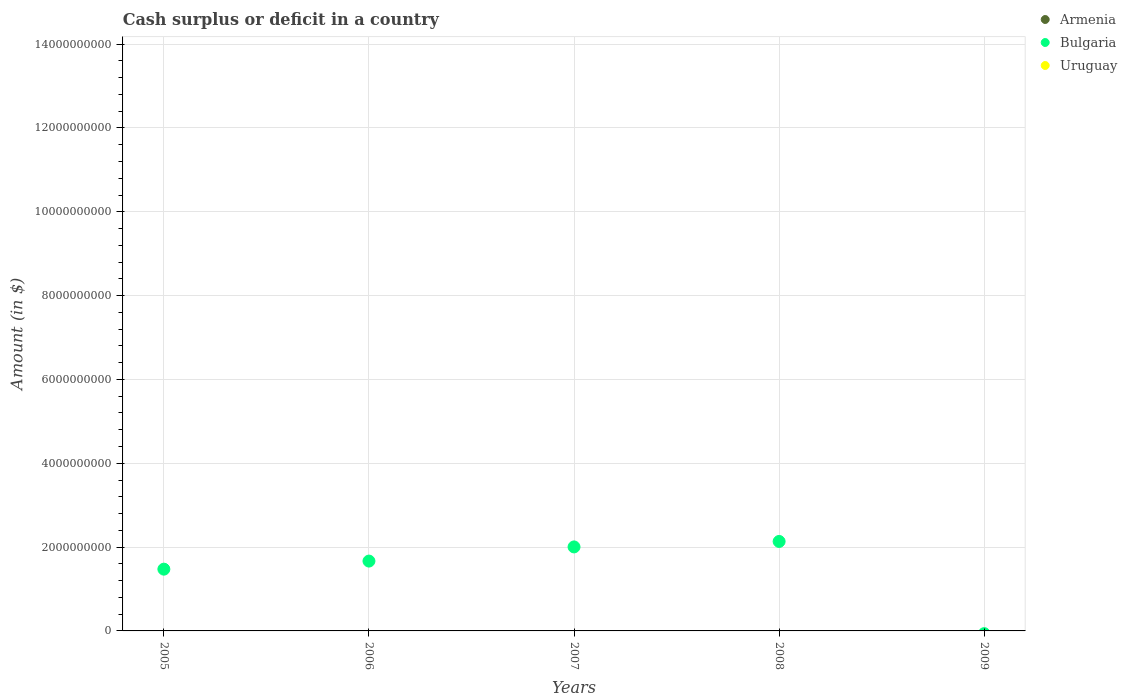How many different coloured dotlines are there?
Offer a very short reply. 1. What is the amount of cash surplus or deficit in Armenia in 2008?
Ensure brevity in your answer.  0. In which year was the amount of cash surplus or deficit in Bulgaria maximum?
Give a very brief answer. 2008. What is the total amount of cash surplus or deficit in Uruguay in the graph?
Your answer should be very brief. 0. What is the difference between the amount of cash surplus or deficit in Bulgaria in 2005 and that in 2006?
Your answer should be compact. -1.93e+08. What is the difference between the amount of cash surplus or deficit in Bulgaria in 2007 and the amount of cash surplus or deficit in Armenia in 2009?
Your response must be concise. 2.00e+09. What is the average amount of cash surplus or deficit in Bulgaria per year?
Make the answer very short. 1.46e+09. In how many years, is the amount of cash surplus or deficit in Uruguay greater than 13200000000 $?
Ensure brevity in your answer.  0. What is the ratio of the amount of cash surplus or deficit in Bulgaria in 2005 to that in 2008?
Your answer should be very brief. 0.69. What is the difference between the highest and the lowest amount of cash surplus or deficit in Bulgaria?
Your answer should be very brief. 2.13e+09. Is the sum of the amount of cash surplus or deficit in Bulgaria in 2005 and 2007 greater than the maximum amount of cash surplus or deficit in Armenia across all years?
Keep it short and to the point. Yes. How many years are there in the graph?
Keep it short and to the point. 5. What is the difference between two consecutive major ticks on the Y-axis?
Your answer should be compact. 2.00e+09. Are the values on the major ticks of Y-axis written in scientific E-notation?
Make the answer very short. No. Where does the legend appear in the graph?
Your answer should be very brief. Top right. How many legend labels are there?
Your answer should be compact. 3. How are the legend labels stacked?
Ensure brevity in your answer.  Vertical. What is the title of the graph?
Your answer should be very brief. Cash surplus or deficit in a country. What is the label or title of the Y-axis?
Make the answer very short. Amount (in $). What is the Amount (in $) of Bulgaria in 2005?
Make the answer very short. 1.47e+09. What is the Amount (in $) in Uruguay in 2005?
Ensure brevity in your answer.  0. What is the Amount (in $) in Bulgaria in 2006?
Ensure brevity in your answer.  1.67e+09. What is the Amount (in $) of Uruguay in 2006?
Your answer should be very brief. 0. What is the Amount (in $) in Bulgaria in 2007?
Offer a very short reply. 2.00e+09. What is the Amount (in $) in Bulgaria in 2008?
Give a very brief answer. 2.13e+09. What is the Amount (in $) of Uruguay in 2008?
Ensure brevity in your answer.  0. What is the Amount (in $) of Uruguay in 2009?
Provide a short and direct response. 0. Across all years, what is the maximum Amount (in $) in Bulgaria?
Offer a very short reply. 2.13e+09. What is the total Amount (in $) of Armenia in the graph?
Your response must be concise. 0. What is the total Amount (in $) in Bulgaria in the graph?
Make the answer very short. 7.28e+09. What is the total Amount (in $) of Uruguay in the graph?
Offer a very short reply. 0. What is the difference between the Amount (in $) of Bulgaria in 2005 and that in 2006?
Give a very brief answer. -1.93e+08. What is the difference between the Amount (in $) of Bulgaria in 2005 and that in 2007?
Offer a terse response. -5.31e+08. What is the difference between the Amount (in $) in Bulgaria in 2005 and that in 2008?
Your answer should be compact. -6.61e+08. What is the difference between the Amount (in $) of Bulgaria in 2006 and that in 2007?
Your answer should be compact. -3.38e+08. What is the difference between the Amount (in $) in Bulgaria in 2006 and that in 2008?
Give a very brief answer. -4.68e+08. What is the difference between the Amount (in $) in Bulgaria in 2007 and that in 2008?
Offer a very short reply. -1.30e+08. What is the average Amount (in $) of Bulgaria per year?
Your answer should be very brief. 1.46e+09. What is the ratio of the Amount (in $) of Bulgaria in 2005 to that in 2006?
Offer a terse response. 0.88. What is the ratio of the Amount (in $) in Bulgaria in 2005 to that in 2007?
Provide a succinct answer. 0.74. What is the ratio of the Amount (in $) in Bulgaria in 2005 to that in 2008?
Your answer should be compact. 0.69. What is the ratio of the Amount (in $) in Bulgaria in 2006 to that in 2007?
Provide a succinct answer. 0.83. What is the ratio of the Amount (in $) in Bulgaria in 2006 to that in 2008?
Your response must be concise. 0.78. What is the ratio of the Amount (in $) in Bulgaria in 2007 to that in 2008?
Give a very brief answer. 0.94. What is the difference between the highest and the second highest Amount (in $) in Bulgaria?
Offer a very short reply. 1.30e+08. What is the difference between the highest and the lowest Amount (in $) of Bulgaria?
Provide a short and direct response. 2.13e+09. 